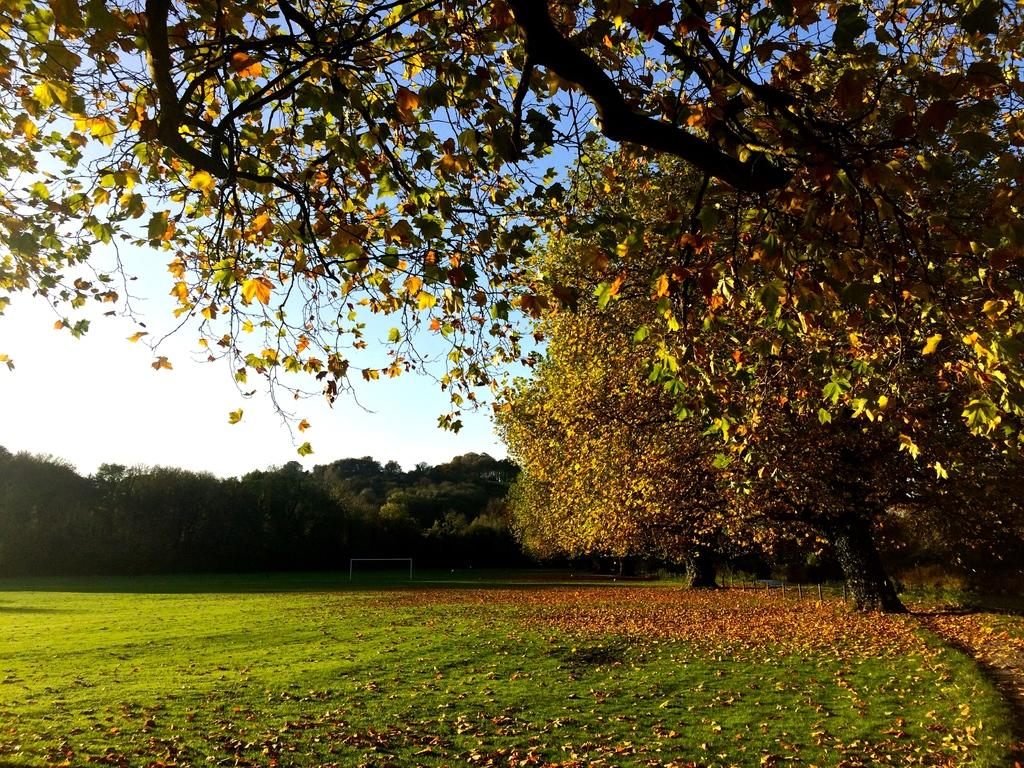What type of vegetation can be seen in the background of the image? There are many trees in the background of the image. What is the ground like where the trees are located? The trees are located on a grassland. Are there any trees shedding leaves in the image? Yes, there are trees shedding leaves on the land on the right side of the image. What type of payment system is being used for the distribution of heat in the image? There is no payment system or heat distribution system present in the image; it features trees on a grassland. 